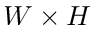Convert formula to latex. <formula><loc_0><loc_0><loc_500><loc_500>W \times H</formula> 